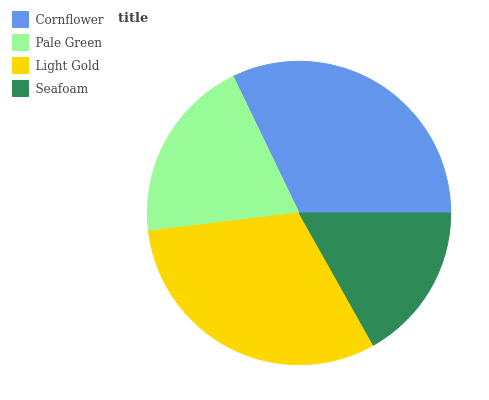Is Seafoam the minimum?
Answer yes or no. Yes. Is Cornflower the maximum?
Answer yes or no. Yes. Is Pale Green the minimum?
Answer yes or no. No. Is Pale Green the maximum?
Answer yes or no. No. Is Cornflower greater than Pale Green?
Answer yes or no. Yes. Is Pale Green less than Cornflower?
Answer yes or no. Yes. Is Pale Green greater than Cornflower?
Answer yes or no. No. Is Cornflower less than Pale Green?
Answer yes or no. No. Is Light Gold the high median?
Answer yes or no. Yes. Is Pale Green the low median?
Answer yes or no. Yes. Is Pale Green the high median?
Answer yes or no. No. Is Light Gold the low median?
Answer yes or no. No. 